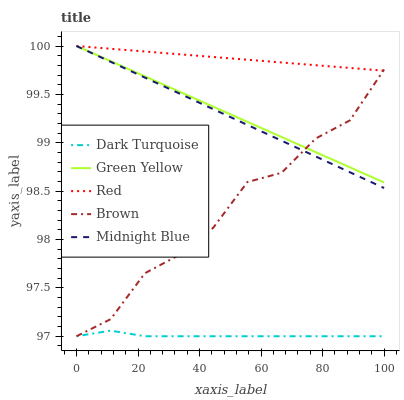Does Dark Turquoise have the minimum area under the curve?
Answer yes or no. Yes. Does Green Yellow have the minimum area under the curve?
Answer yes or no. No. Does Green Yellow have the maximum area under the curve?
Answer yes or no. No. Is Midnight Blue the smoothest?
Answer yes or no. No. Is Midnight Blue the roughest?
Answer yes or no. No. Does Green Yellow have the lowest value?
Answer yes or no. No. Does Brown have the highest value?
Answer yes or no. No. Is Dark Turquoise less than Midnight Blue?
Answer yes or no. Yes. Is Midnight Blue greater than Dark Turquoise?
Answer yes or no. Yes. Does Dark Turquoise intersect Midnight Blue?
Answer yes or no. No. 